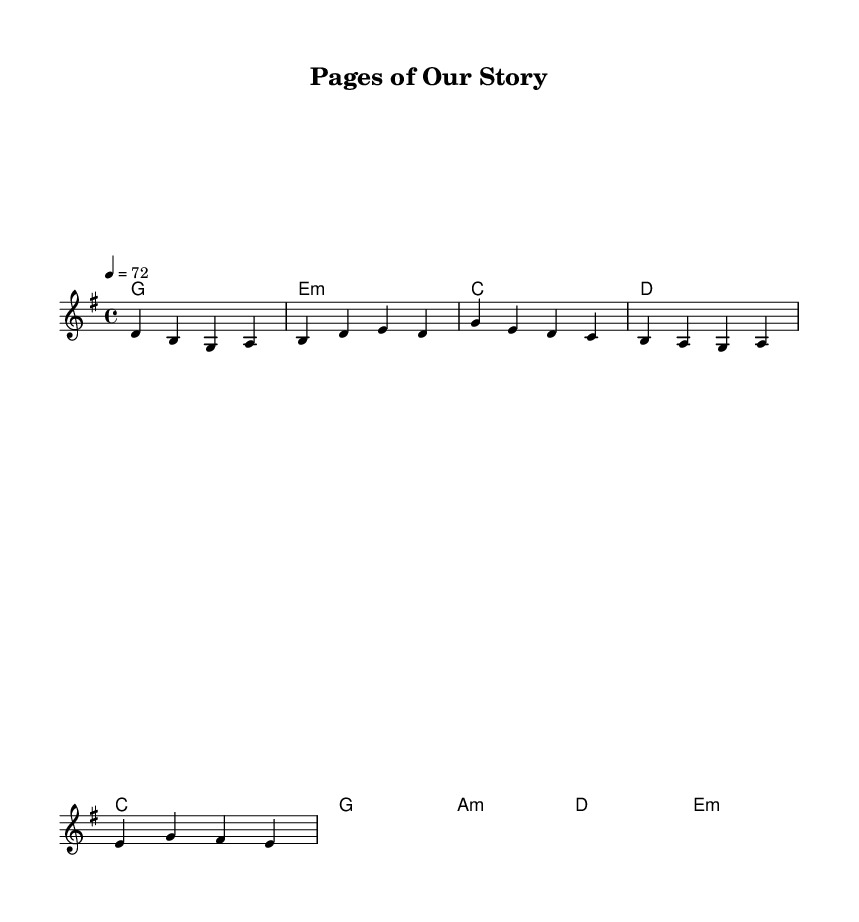What is the key signature of this music? The key signature is shown at the beginning of the score, indicating that the piece is in G major. G major has one sharp, which is F#.
Answer: G major What is the time signature of this music? The time signature appears at the start of the sheet music. Here, it shows 4/4, indicating there are four beats in a measure and the quarter note gets one beat.
Answer: 4/4 What is the tempo marking for this piece? The tempo marking is found above the staff, which states "4 = 72." This indicates the speed at which the piece should be played, specifically 72 beats per minute.
Answer: 72 How many measures are there in the verse? By counting the individual groups of notes in the verse section, there are a total of four measures used. Each bar is separated by a vertical line on the staff.
Answer: 4 What literary reference is mentioned in the lyrics? The lyrics refer to "Hemingway's old man and the sea," which is a direct reference to the novel by Ernest Hemingway. This is a well-known literary work that fits the theme of struggle.
Answer: Hemingway What poetic device is used in the chorus? The lyrics of the chorus include the phrase "alliteration in every detail." This indicates the use of alliteration, a poetic device where the same initial consonant sound is repeated in close succession.
Answer: Alliteration What is the structure of the song? The song consists of a verse, a chorus, and a bridge, which is a common structure in ballads, allowing for narrative progression followed by thematic emphasis.
Answer: Verse, Chorus, Bridge 